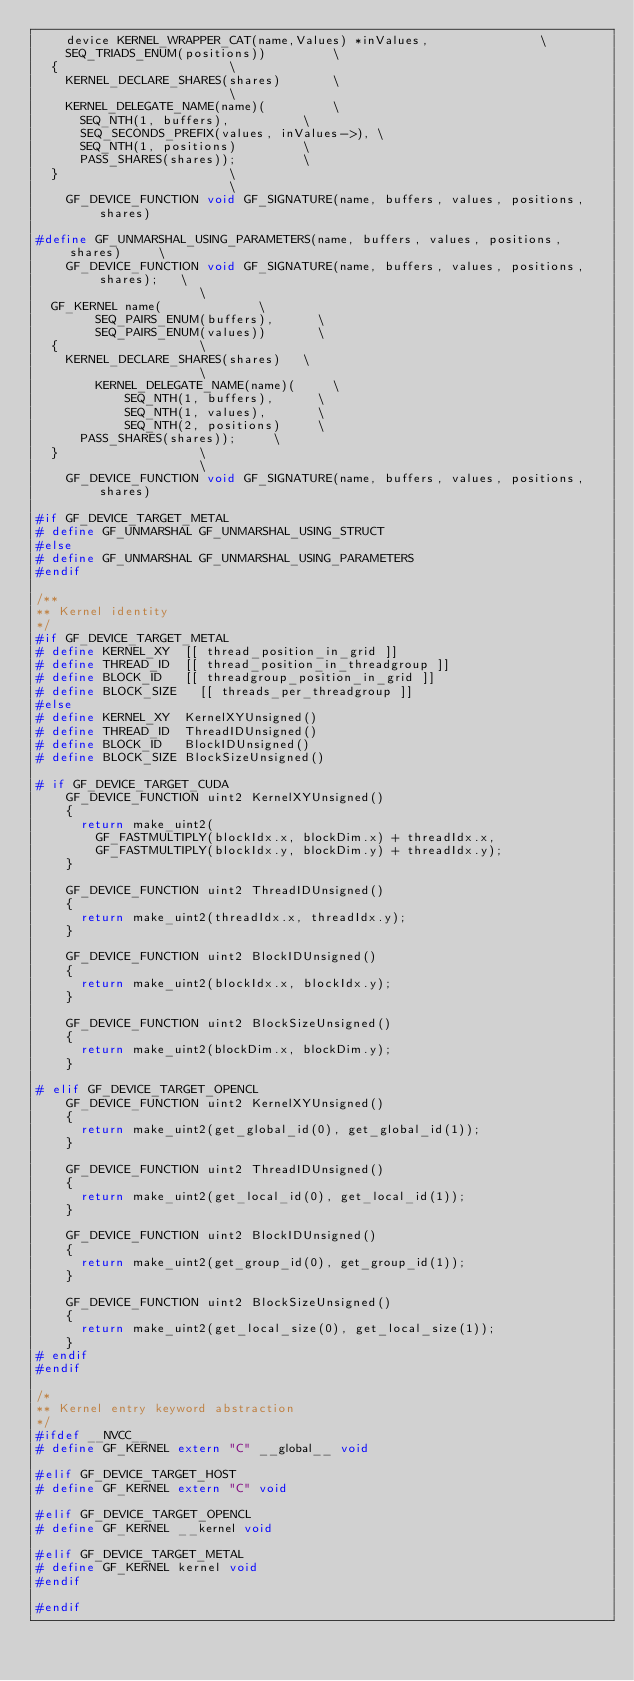Convert code to text. <code><loc_0><loc_0><loc_500><loc_500><_C_>		device KERNEL_WRAPPER_CAT(name,Values) *inValues,								\
		SEQ_TRIADS_ENUM(positions))					\
	{												\
		KERNEL_DECLARE_SHARES(shares)				\
													\
		KERNEL_DELEGATE_NAME(name)(					\
			SEQ_NTH(1, buffers),					\
			SEQ_SECONDS_PREFIX(values, inValues->),	\
			SEQ_NTH(1, positions)					\
			PASS_SHARES(shares));					\
	}												\
													\
    GF_DEVICE_FUNCTION void GF_SIGNATURE(name, buffers, values, positions, shares)

#define GF_UNMARSHAL_USING_PARAMETERS(name, buffers, values, positions, shares)			\
    GF_DEVICE_FUNCTION void GF_SIGNATURE(name, buffers, values, positions, shares);		\
											\
	GF_KERNEL name(							\
        SEQ_PAIRS_ENUM(buffers),			\
        SEQ_PAIRS_ENUM(values))				\
	{										\
		KERNEL_DECLARE_SHARES(shares)		\
											\
        KERNEL_DELEGATE_NAME(name)(			\
            SEQ_NTH(1, buffers),			\
            SEQ_NTH(1, values),				\
            SEQ_NTH(2, positions)			\
			PASS_SHARES(shares));			\
	}										\
											\
    GF_DEVICE_FUNCTION void GF_SIGNATURE(name, buffers, values, positions, shares)

#if GF_DEVICE_TARGET_METAL
#	define GF_UNMARSHAL GF_UNMARSHAL_USING_STRUCT
#else
#	define GF_UNMARSHAL GF_UNMARSHAL_USING_PARAMETERS
#endif

/**
** Kernel identity 
*/
#if GF_DEVICE_TARGET_METAL
#	define KERNEL_XY	[[ thread_position_in_grid ]]
#	define THREAD_ID	[[ thread_position_in_threadgroup ]]
#	define BLOCK_ID 	[[ threadgroup_position_in_grid ]]
#	define BLOCK_SIZE 	[[ threads_per_threadgroup ]]
#else
#	define KERNEL_XY	KernelXYUnsigned()
#	define THREAD_ID	ThreadIDUnsigned()
#	define BLOCK_ID		BlockIDUnsigned()
#	define BLOCK_SIZE	BlockSizeUnsigned()

#	if GF_DEVICE_TARGET_CUDA
		GF_DEVICE_FUNCTION uint2 KernelXYUnsigned()
		{
			return make_uint2(
				GF_FASTMULTIPLY(blockIdx.x, blockDim.x) + threadIdx.x,
				GF_FASTMULTIPLY(blockIdx.y, blockDim.y) + threadIdx.y);
		}

		GF_DEVICE_FUNCTION uint2 ThreadIDUnsigned()
		{
			return make_uint2(threadIdx.x, threadIdx.y);
		}

		GF_DEVICE_FUNCTION uint2 BlockIDUnsigned()
		{
			return make_uint2(blockIdx.x, blockIdx.y);
		}

		GF_DEVICE_FUNCTION uint2 BlockSizeUnsigned()
		{
			return make_uint2(blockDim.x, blockDim.y);
		}

#	elif GF_DEVICE_TARGET_OPENCL
		GF_DEVICE_FUNCTION uint2 KernelXYUnsigned()
		{
			return make_uint2(get_global_id(0), get_global_id(1));
		}

		GF_DEVICE_FUNCTION uint2 ThreadIDUnsigned()
		{
			return make_uint2(get_local_id(0), get_local_id(1));
		}

		GF_DEVICE_FUNCTION uint2 BlockIDUnsigned()
		{
			return make_uint2(get_group_id(0), get_group_id(1));
		}

		GF_DEVICE_FUNCTION uint2 BlockSizeUnsigned()
		{
			return make_uint2(get_local_size(0), get_local_size(1));
		}
#	endif
#endif	

/* 
** Kernel entry keyword abstraction
*/
#ifdef __NVCC__
#	define GF_KERNEL extern "C" __global__ void

#elif GF_DEVICE_TARGET_HOST
#	define GF_KERNEL extern "C" void

#elif GF_DEVICE_TARGET_OPENCL
#	define GF_KERNEL __kernel void

#elif GF_DEVICE_TARGET_METAL
#	define GF_KERNEL kernel void
#endif

#endif
</code> 